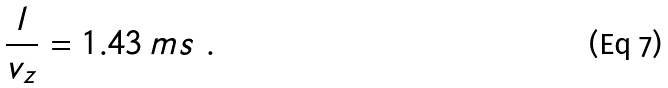Convert formula to latex. <formula><loc_0><loc_0><loc_500><loc_500>\frac { l } { v _ { z } } = 1 . 4 3 \, m s \ .</formula> 